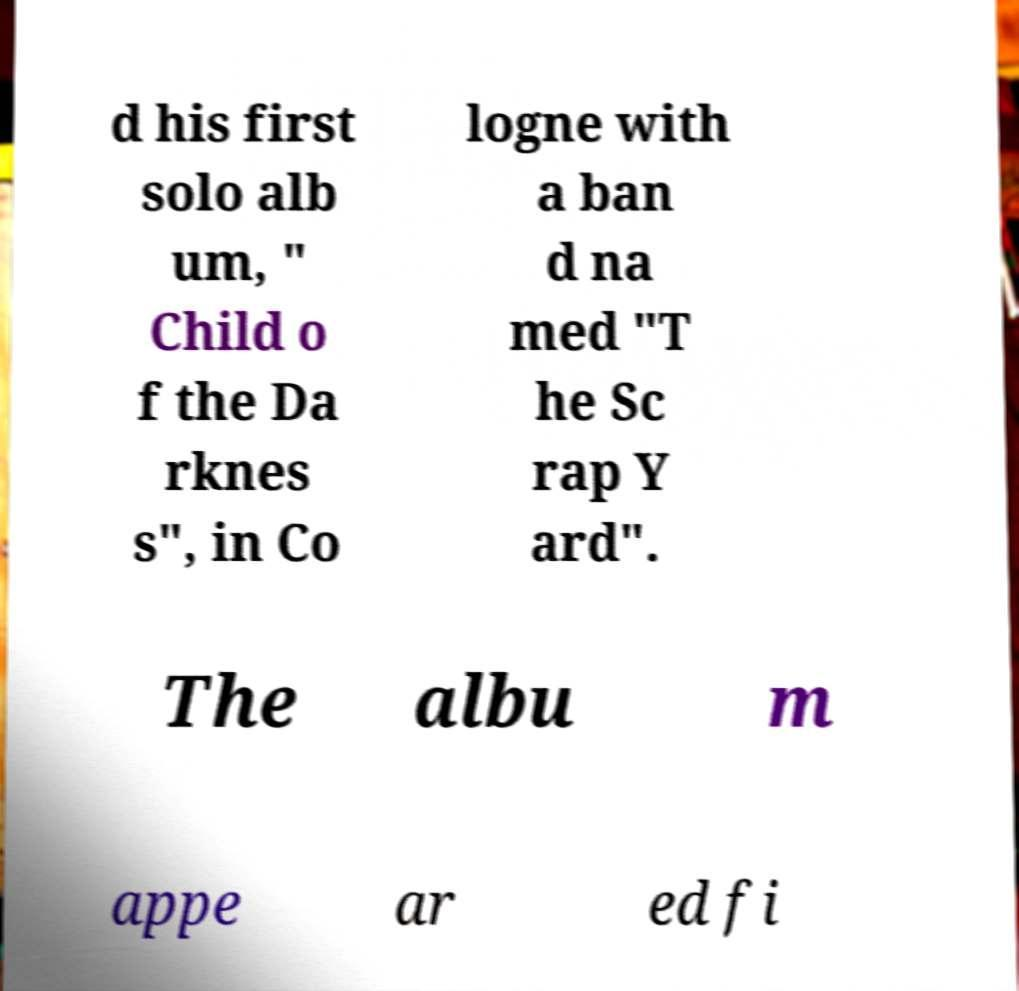I need the written content from this picture converted into text. Can you do that? d his first solo alb um, " Child o f the Da rknes s", in Co logne with a ban d na med "T he Sc rap Y ard". The albu m appe ar ed fi 